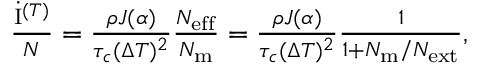Convert formula to latex. <formula><loc_0><loc_0><loc_500><loc_500>\begin{array} { r } { \frac { \dot { I } ^ { ( T ) } } { N } = \frac { \rho J ( \alpha ) } { \tau _ { c } ( \Delta T ) ^ { 2 } } \frac { N _ { e f f } } { N _ { m } } = \frac { \rho J ( \alpha ) } { \tau _ { c } ( \Delta T ) ^ { 2 } } \frac { 1 } { 1 + N _ { m } / N _ { e x t } } , } \end{array}</formula> 